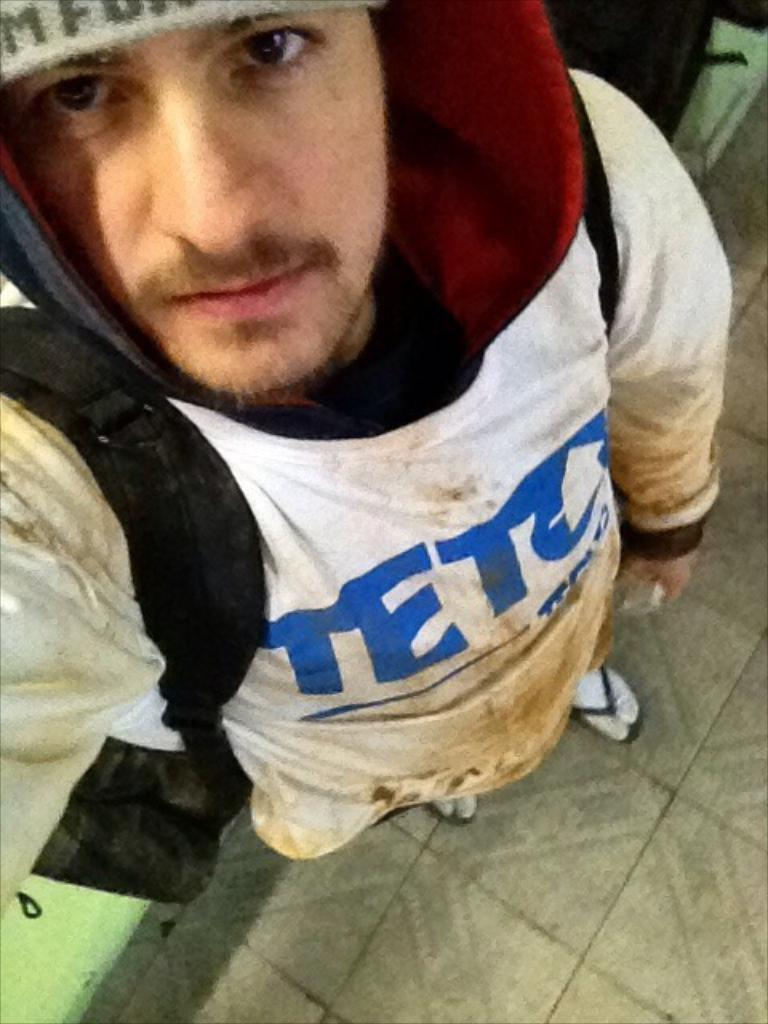Provide a one-sentence caption for the provided image. a man that has the word teto on his shirt. 